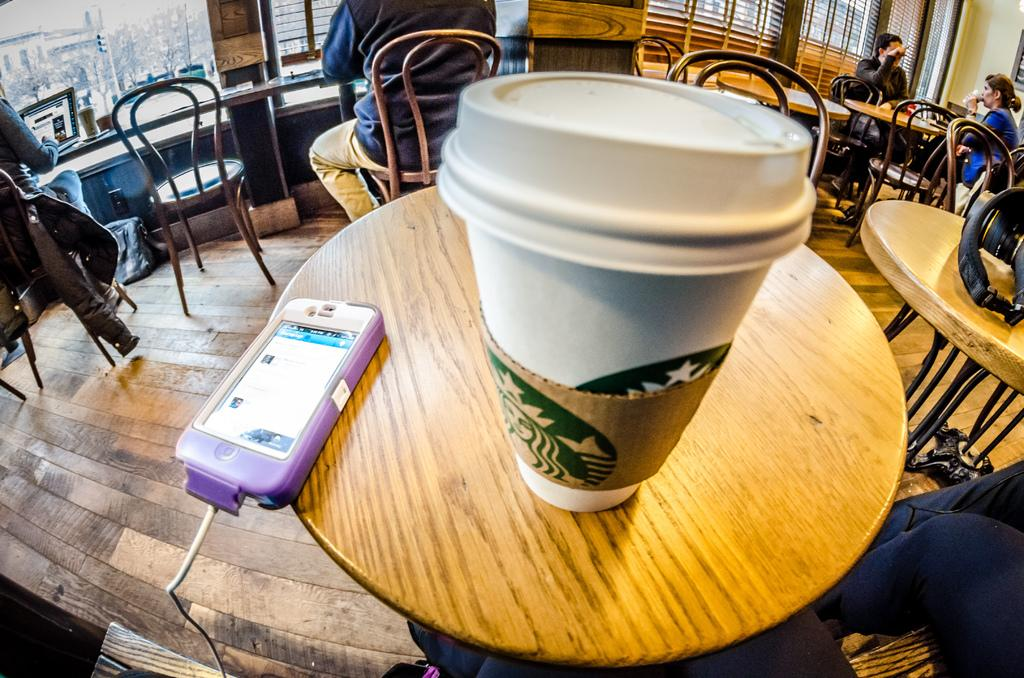What object is placed on the table in the image? There is a cup on a table in the image. What else can be seen on the table in the image? There is a mobile on the table in the image. What are the people in the image doing? The people in the image are seated on chairs. What type of smoke can be seen coming from the cup in the image? There is no smoke coming from the cup in the image. What impulse might have led to the arrangement of the objects in the image? The image does not provide information about the impulse that led to the arrangement of the objects. 